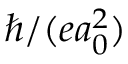<formula> <loc_0><loc_0><loc_500><loc_500>\hbar { / } ( e a _ { 0 } ^ { 2 } )</formula> 